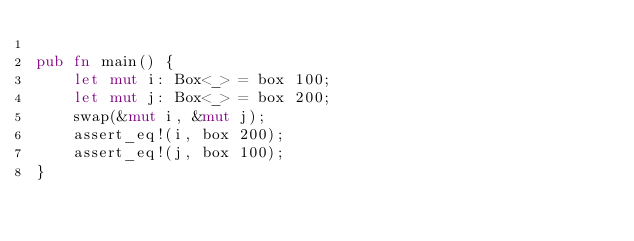Convert code to text. <code><loc_0><loc_0><loc_500><loc_500><_Rust_>
pub fn main() {
    let mut i: Box<_> = box 100;
    let mut j: Box<_> = box 200;
    swap(&mut i, &mut j);
    assert_eq!(i, box 200);
    assert_eq!(j, box 100);
}
</code> 